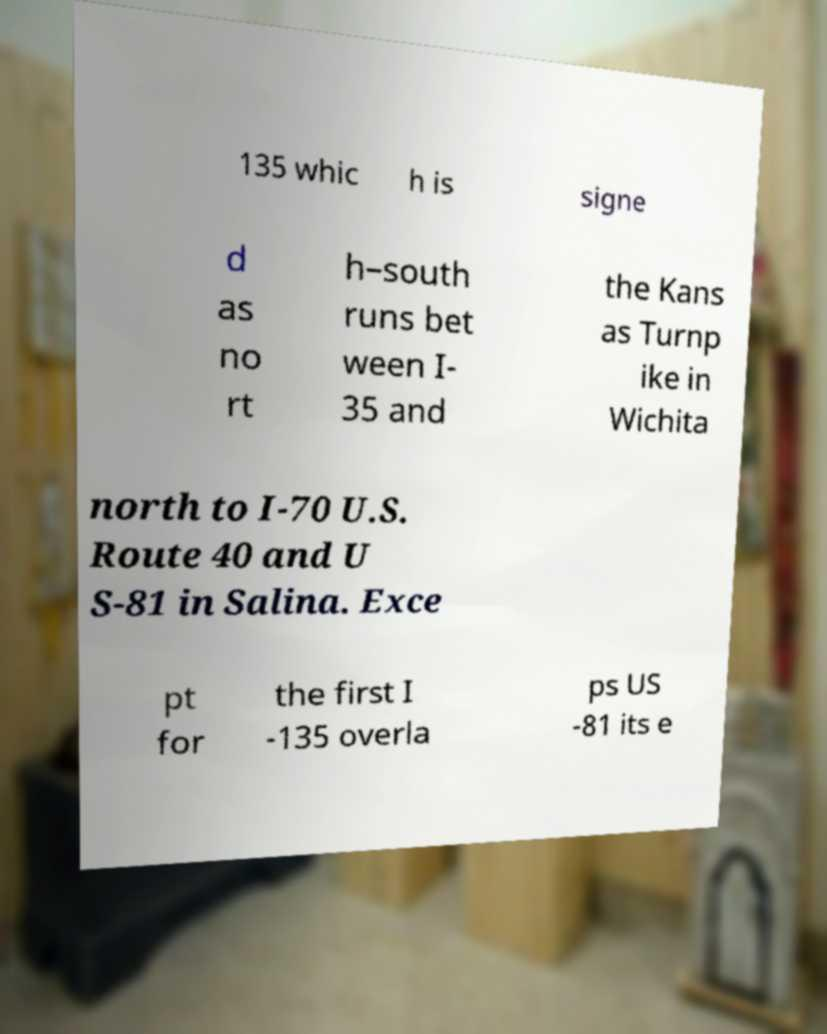Can you accurately transcribe the text from the provided image for me? 135 whic h is signe d as no rt h–south runs bet ween I- 35 and the Kans as Turnp ike in Wichita north to I-70 U.S. Route 40 and U S-81 in Salina. Exce pt for the first I -135 overla ps US -81 its e 